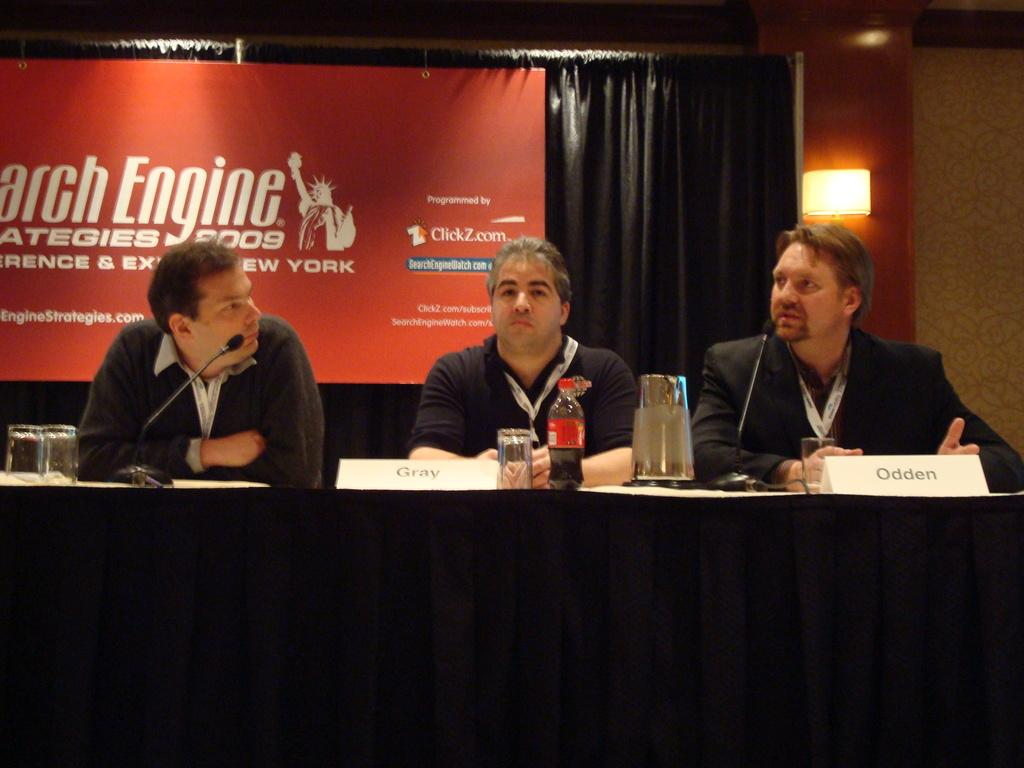What type of furniture is present in the image? There is a table in the image. Who is sitting behind the table? Three men are sitting on chairs behind the table. What can be seen in the background of the image? There is a black curtain and a poster in the background. What type of silk fabric is being used for the addition in the image? There is no mention of silk fabric or an addition in the image. 